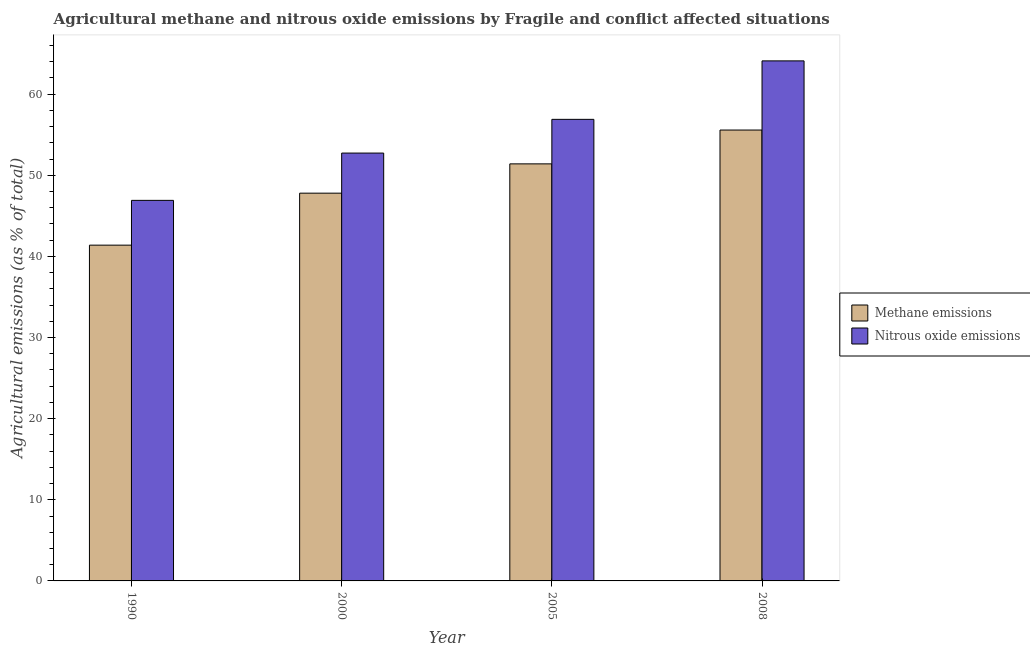How many different coloured bars are there?
Make the answer very short. 2. How many groups of bars are there?
Your answer should be compact. 4. Are the number of bars per tick equal to the number of legend labels?
Keep it short and to the point. Yes. Are the number of bars on each tick of the X-axis equal?
Give a very brief answer. Yes. How many bars are there on the 4th tick from the left?
Your answer should be very brief. 2. How many bars are there on the 1st tick from the right?
Your response must be concise. 2. What is the amount of methane emissions in 1990?
Keep it short and to the point. 41.39. Across all years, what is the maximum amount of nitrous oxide emissions?
Provide a succinct answer. 64.1. Across all years, what is the minimum amount of methane emissions?
Your answer should be very brief. 41.39. In which year was the amount of methane emissions maximum?
Offer a terse response. 2008. What is the total amount of nitrous oxide emissions in the graph?
Ensure brevity in your answer.  220.65. What is the difference between the amount of methane emissions in 1990 and that in 2008?
Your answer should be very brief. -14.19. What is the difference between the amount of methane emissions in 1990 and the amount of nitrous oxide emissions in 2008?
Your response must be concise. -14.19. What is the average amount of methane emissions per year?
Ensure brevity in your answer.  49.04. In how many years, is the amount of methane emissions greater than 52 %?
Provide a short and direct response. 1. What is the ratio of the amount of nitrous oxide emissions in 1990 to that in 2008?
Your answer should be compact. 0.73. Is the difference between the amount of methane emissions in 1990 and 2005 greater than the difference between the amount of nitrous oxide emissions in 1990 and 2005?
Provide a short and direct response. No. What is the difference between the highest and the second highest amount of methane emissions?
Your response must be concise. 4.17. What is the difference between the highest and the lowest amount of nitrous oxide emissions?
Keep it short and to the point. 17.19. In how many years, is the amount of nitrous oxide emissions greater than the average amount of nitrous oxide emissions taken over all years?
Offer a terse response. 2. What does the 1st bar from the left in 1990 represents?
Provide a short and direct response. Methane emissions. What does the 1st bar from the right in 2005 represents?
Provide a succinct answer. Nitrous oxide emissions. How many years are there in the graph?
Keep it short and to the point. 4. What is the difference between two consecutive major ticks on the Y-axis?
Offer a very short reply. 10. Does the graph contain any zero values?
Your response must be concise. No. Where does the legend appear in the graph?
Keep it short and to the point. Center right. How are the legend labels stacked?
Your response must be concise. Vertical. What is the title of the graph?
Offer a terse response. Agricultural methane and nitrous oxide emissions by Fragile and conflict affected situations. Does "Methane emissions" appear as one of the legend labels in the graph?
Your answer should be very brief. Yes. What is the label or title of the X-axis?
Keep it short and to the point. Year. What is the label or title of the Y-axis?
Provide a succinct answer. Agricultural emissions (as % of total). What is the Agricultural emissions (as % of total) in Methane emissions in 1990?
Your answer should be very brief. 41.39. What is the Agricultural emissions (as % of total) in Nitrous oxide emissions in 1990?
Your response must be concise. 46.91. What is the Agricultural emissions (as % of total) in Methane emissions in 2000?
Your answer should be very brief. 47.8. What is the Agricultural emissions (as % of total) in Nitrous oxide emissions in 2000?
Make the answer very short. 52.74. What is the Agricultural emissions (as % of total) of Methane emissions in 2005?
Your response must be concise. 51.41. What is the Agricultural emissions (as % of total) in Nitrous oxide emissions in 2005?
Offer a terse response. 56.9. What is the Agricultural emissions (as % of total) of Methane emissions in 2008?
Give a very brief answer. 55.58. What is the Agricultural emissions (as % of total) in Nitrous oxide emissions in 2008?
Offer a very short reply. 64.1. Across all years, what is the maximum Agricultural emissions (as % of total) in Methane emissions?
Your response must be concise. 55.58. Across all years, what is the maximum Agricultural emissions (as % of total) in Nitrous oxide emissions?
Your answer should be very brief. 64.1. Across all years, what is the minimum Agricultural emissions (as % of total) of Methane emissions?
Your answer should be compact. 41.39. Across all years, what is the minimum Agricultural emissions (as % of total) in Nitrous oxide emissions?
Make the answer very short. 46.91. What is the total Agricultural emissions (as % of total) of Methane emissions in the graph?
Ensure brevity in your answer.  196.17. What is the total Agricultural emissions (as % of total) in Nitrous oxide emissions in the graph?
Provide a short and direct response. 220.65. What is the difference between the Agricultural emissions (as % of total) in Methane emissions in 1990 and that in 2000?
Ensure brevity in your answer.  -6.41. What is the difference between the Agricultural emissions (as % of total) of Nitrous oxide emissions in 1990 and that in 2000?
Your response must be concise. -5.83. What is the difference between the Agricultural emissions (as % of total) in Methane emissions in 1990 and that in 2005?
Offer a very short reply. -10.02. What is the difference between the Agricultural emissions (as % of total) of Nitrous oxide emissions in 1990 and that in 2005?
Make the answer very short. -9.99. What is the difference between the Agricultural emissions (as % of total) of Methane emissions in 1990 and that in 2008?
Your answer should be very brief. -14.19. What is the difference between the Agricultural emissions (as % of total) of Nitrous oxide emissions in 1990 and that in 2008?
Your answer should be compact. -17.19. What is the difference between the Agricultural emissions (as % of total) of Methane emissions in 2000 and that in 2005?
Provide a succinct answer. -3.61. What is the difference between the Agricultural emissions (as % of total) of Nitrous oxide emissions in 2000 and that in 2005?
Ensure brevity in your answer.  -4.16. What is the difference between the Agricultural emissions (as % of total) of Methane emissions in 2000 and that in 2008?
Offer a terse response. -7.78. What is the difference between the Agricultural emissions (as % of total) of Nitrous oxide emissions in 2000 and that in 2008?
Your response must be concise. -11.36. What is the difference between the Agricultural emissions (as % of total) in Methane emissions in 2005 and that in 2008?
Ensure brevity in your answer.  -4.17. What is the difference between the Agricultural emissions (as % of total) in Nitrous oxide emissions in 2005 and that in 2008?
Your answer should be very brief. -7.21. What is the difference between the Agricultural emissions (as % of total) in Methane emissions in 1990 and the Agricultural emissions (as % of total) in Nitrous oxide emissions in 2000?
Ensure brevity in your answer.  -11.35. What is the difference between the Agricultural emissions (as % of total) in Methane emissions in 1990 and the Agricultural emissions (as % of total) in Nitrous oxide emissions in 2005?
Offer a terse response. -15.51. What is the difference between the Agricultural emissions (as % of total) in Methane emissions in 1990 and the Agricultural emissions (as % of total) in Nitrous oxide emissions in 2008?
Provide a short and direct response. -22.71. What is the difference between the Agricultural emissions (as % of total) of Methane emissions in 2000 and the Agricultural emissions (as % of total) of Nitrous oxide emissions in 2005?
Keep it short and to the point. -9.1. What is the difference between the Agricultural emissions (as % of total) in Methane emissions in 2000 and the Agricultural emissions (as % of total) in Nitrous oxide emissions in 2008?
Your response must be concise. -16.31. What is the difference between the Agricultural emissions (as % of total) of Methane emissions in 2005 and the Agricultural emissions (as % of total) of Nitrous oxide emissions in 2008?
Your response must be concise. -12.69. What is the average Agricultural emissions (as % of total) of Methane emissions per year?
Keep it short and to the point. 49.04. What is the average Agricultural emissions (as % of total) in Nitrous oxide emissions per year?
Ensure brevity in your answer.  55.16. In the year 1990, what is the difference between the Agricultural emissions (as % of total) of Methane emissions and Agricultural emissions (as % of total) of Nitrous oxide emissions?
Offer a very short reply. -5.52. In the year 2000, what is the difference between the Agricultural emissions (as % of total) in Methane emissions and Agricultural emissions (as % of total) in Nitrous oxide emissions?
Offer a terse response. -4.94. In the year 2005, what is the difference between the Agricultural emissions (as % of total) in Methane emissions and Agricultural emissions (as % of total) in Nitrous oxide emissions?
Provide a short and direct response. -5.49. In the year 2008, what is the difference between the Agricultural emissions (as % of total) in Methane emissions and Agricultural emissions (as % of total) in Nitrous oxide emissions?
Keep it short and to the point. -8.53. What is the ratio of the Agricultural emissions (as % of total) of Methane emissions in 1990 to that in 2000?
Provide a short and direct response. 0.87. What is the ratio of the Agricultural emissions (as % of total) of Nitrous oxide emissions in 1990 to that in 2000?
Provide a succinct answer. 0.89. What is the ratio of the Agricultural emissions (as % of total) of Methane emissions in 1990 to that in 2005?
Ensure brevity in your answer.  0.81. What is the ratio of the Agricultural emissions (as % of total) of Nitrous oxide emissions in 1990 to that in 2005?
Your response must be concise. 0.82. What is the ratio of the Agricultural emissions (as % of total) of Methane emissions in 1990 to that in 2008?
Provide a short and direct response. 0.74. What is the ratio of the Agricultural emissions (as % of total) in Nitrous oxide emissions in 1990 to that in 2008?
Keep it short and to the point. 0.73. What is the ratio of the Agricultural emissions (as % of total) of Methane emissions in 2000 to that in 2005?
Provide a short and direct response. 0.93. What is the ratio of the Agricultural emissions (as % of total) in Nitrous oxide emissions in 2000 to that in 2005?
Offer a terse response. 0.93. What is the ratio of the Agricultural emissions (as % of total) in Methane emissions in 2000 to that in 2008?
Give a very brief answer. 0.86. What is the ratio of the Agricultural emissions (as % of total) in Nitrous oxide emissions in 2000 to that in 2008?
Give a very brief answer. 0.82. What is the ratio of the Agricultural emissions (as % of total) of Methane emissions in 2005 to that in 2008?
Ensure brevity in your answer.  0.93. What is the ratio of the Agricultural emissions (as % of total) of Nitrous oxide emissions in 2005 to that in 2008?
Your answer should be compact. 0.89. What is the difference between the highest and the second highest Agricultural emissions (as % of total) in Methane emissions?
Your answer should be compact. 4.17. What is the difference between the highest and the second highest Agricultural emissions (as % of total) of Nitrous oxide emissions?
Your response must be concise. 7.21. What is the difference between the highest and the lowest Agricultural emissions (as % of total) in Methane emissions?
Keep it short and to the point. 14.19. What is the difference between the highest and the lowest Agricultural emissions (as % of total) in Nitrous oxide emissions?
Ensure brevity in your answer.  17.19. 